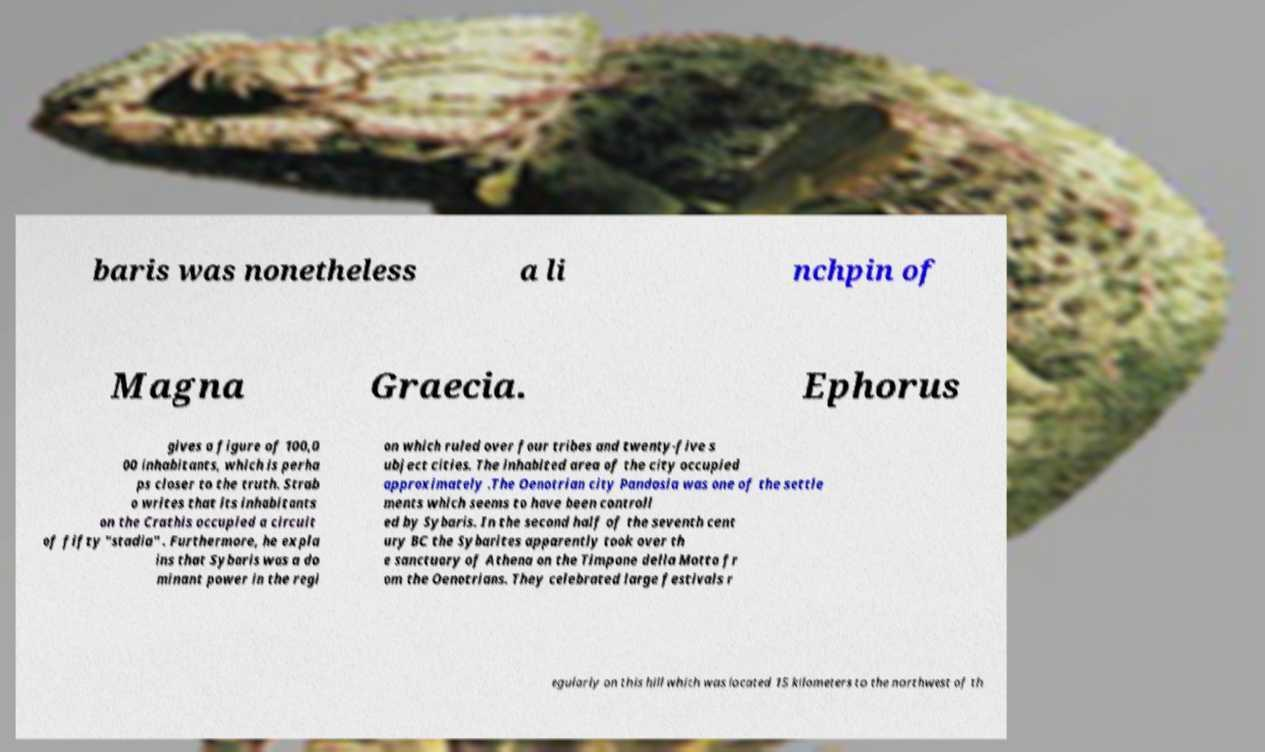I need the written content from this picture converted into text. Can you do that? baris was nonetheless a li nchpin of Magna Graecia. Ephorus gives a figure of 100,0 00 inhabitants, which is perha ps closer to the truth. Strab o writes that its inhabitants on the Crathis occupied a circuit of fifty "stadia" . Furthermore, he expla ins that Sybaris was a do minant power in the regi on which ruled over four tribes and twenty-five s ubject cities. The inhabited area of the city occupied approximately .The Oenotrian city Pandosia was one of the settle ments which seems to have been controll ed by Sybaris. In the second half of the seventh cent ury BC the Sybarites apparently took over th e sanctuary of Athena on the Timpone della Motta fr om the Oenotrians. They celebrated large festivals r egularly on this hill which was located 15 kilometers to the northwest of th 